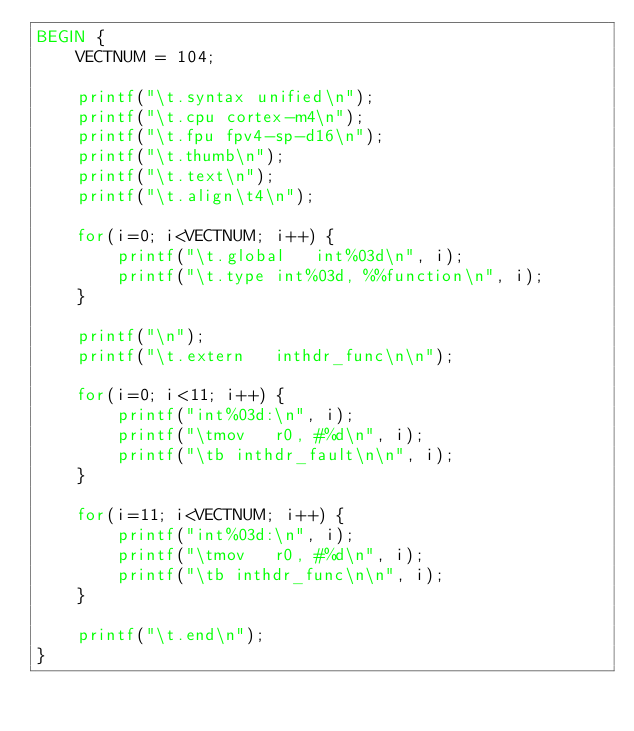<code> <loc_0><loc_0><loc_500><loc_500><_Awk_>BEGIN {
	VECTNUM = 104;

	printf("\t.syntax unified\n");
	printf("\t.cpu cortex-m4\n");
	printf("\t.fpu fpv4-sp-d16\n");
	printf("\t.thumb\n");
	printf("\t.text\n");
	printf("\t.align\t4\n");

	for(i=0; i<VECTNUM; i++) {
		printf("\t.global	int%03d\n", i);
		printf("\t.type	int%03d, %%function\n", i);
	}

	printf("\n");
	printf("\t.extern	inthdr_func\n\n");

	for(i=0; i<11; i++) {
		printf("int%03d:\n", i);
		printf("\tmov	r0, #%d\n", i);
		printf("\tb	inthdr_fault\n\n", i);
	}

	for(i=11; i<VECTNUM; i++) {
		printf("int%03d:\n", i);
		printf("\tmov	r0, #%d\n", i);
		printf("\tb	inthdr_func\n\n", i);
	}

	printf("\t.end\n");
}
</code> 